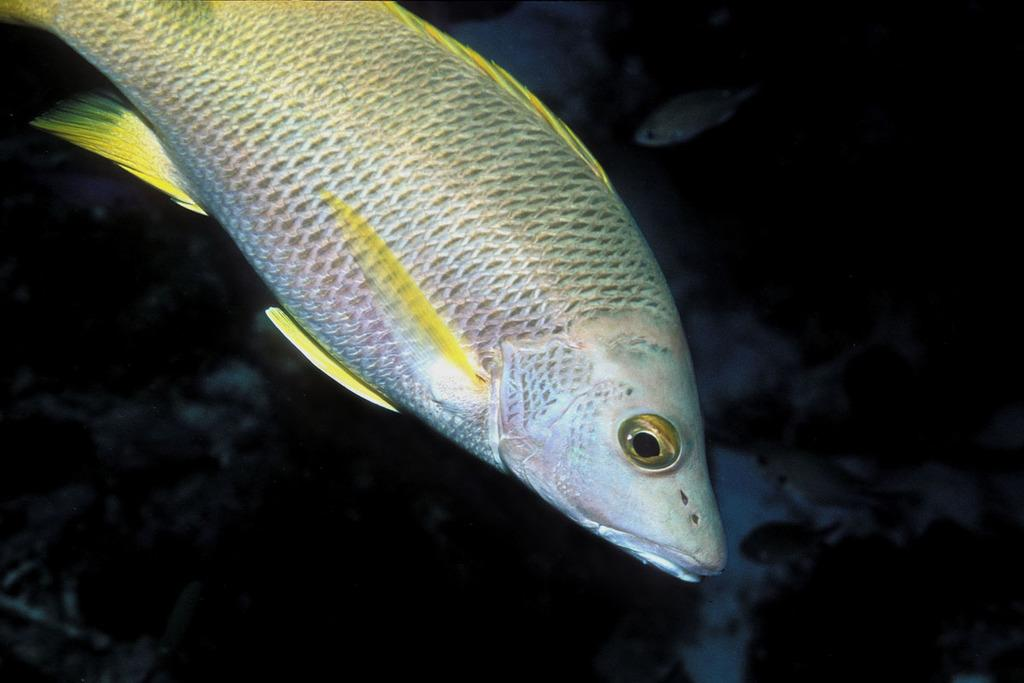What is the main subject in the foreground of the image? There is a fish in the foreground of the image. What can be seen in the background of the image? There is a shoal of fishes in the background of the image. Where do you think the image was taken? The image appears to be taken in the ocean. What time of day does the image seem to depict? The image seems to be taken during nighttime. What type of insect can be seen crawling on the cellar wall in the image? There is no insect or cellar present in the image; it features a fish in the foreground and a shoal of fishes in the background, taken in the ocean during nighttime. 